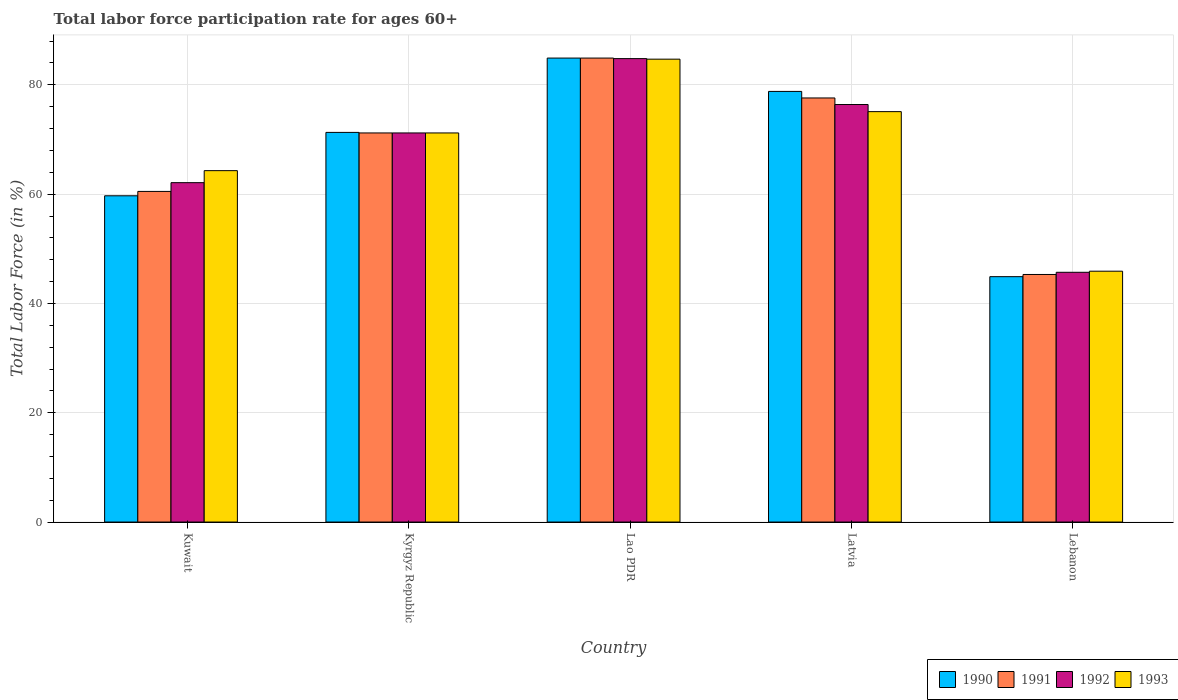How many groups of bars are there?
Give a very brief answer. 5. Are the number of bars on each tick of the X-axis equal?
Your answer should be very brief. Yes. What is the label of the 3rd group of bars from the left?
Give a very brief answer. Lao PDR. In how many cases, is the number of bars for a given country not equal to the number of legend labels?
Make the answer very short. 0. What is the labor force participation rate in 1993 in Lao PDR?
Your response must be concise. 84.7. Across all countries, what is the maximum labor force participation rate in 1992?
Provide a succinct answer. 84.8. Across all countries, what is the minimum labor force participation rate in 1992?
Ensure brevity in your answer.  45.7. In which country was the labor force participation rate in 1991 maximum?
Keep it short and to the point. Lao PDR. In which country was the labor force participation rate in 1992 minimum?
Provide a succinct answer. Lebanon. What is the total labor force participation rate in 1992 in the graph?
Provide a short and direct response. 340.2. What is the difference between the labor force participation rate in 1993 in Kuwait and that in Latvia?
Give a very brief answer. -10.8. What is the difference between the labor force participation rate in 1990 in Lebanon and the labor force participation rate in 1991 in Latvia?
Provide a short and direct response. -32.7. What is the average labor force participation rate in 1992 per country?
Your answer should be compact. 68.04. In how many countries, is the labor force participation rate in 1990 greater than 56 %?
Your answer should be very brief. 4. What is the ratio of the labor force participation rate in 1992 in Kuwait to that in Lebanon?
Keep it short and to the point. 1.36. Is the labor force participation rate in 1993 in Kyrgyz Republic less than that in Latvia?
Provide a short and direct response. Yes. Is the difference between the labor force participation rate in 1991 in Lao PDR and Lebanon greater than the difference between the labor force participation rate in 1990 in Lao PDR and Lebanon?
Provide a short and direct response. No. What is the difference between the highest and the second highest labor force participation rate in 1992?
Ensure brevity in your answer.  13.6. What is the difference between the highest and the lowest labor force participation rate in 1991?
Your answer should be compact. 39.6. Is the sum of the labor force participation rate in 1990 in Kyrgyz Republic and Lebanon greater than the maximum labor force participation rate in 1993 across all countries?
Make the answer very short. Yes. Is it the case that in every country, the sum of the labor force participation rate in 1992 and labor force participation rate in 1993 is greater than the sum of labor force participation rate in 1990 and labor force participation rate in 1991?
Provide a short and direct response. No. What does the 3rd bar from the left in Latvia represents?
Offer a very short reply. 1992. Is it the case that in every country, the sum of the labor force participation rate in 1990 and labor force participation rate in 1991 is greater than the labor force participation rate in 1993?
Ensure brevity in your answer.  Yes. How many bars are there?
Your answer should be very brief. 20. Are all the bars in the graph horizontal?
Offer a very short reply. No. Are the values on the major ticks of Y-axis written in scientific E-notation?
Provide a short and direct response. No. Does the graph contain grids?
Give a very brief answer. Yes. Where does the legend appear in the graph?
Provide a succinct answer. Bottom right. What is the title of the graph?
Offer a very short reply. Total labor force participation rate for ages 60+. What is the Total Labor Force (in %) in 1990 in Kuwait?
Provide a short and direct response. 59.7. What is the Total Labor Force (in %) in 1991 in Kuwait?
Your response must be concise. 60.5. What is the Total Labor Force (in %) of 1992 in Kuwait?
Your response must be concise. 62.1. What is the Total Labor Force (in %) of 1993 in Kuwait?
Give a very brief answer. 64.3. What is the Total Labor Force (in %) in 1990 in Kyrgyz Republic?
Make the answer very short. 71.3. What is the Total Labor Force (in %) of 1991 in Kyrgyz Republic?
Give a very brief answer. 71.2. What is the Total Labor Force (in %) in 1992 in Kyrgyz Republic?
Ensure brevity in your answer.  71.2. What is the Total Labor Force (in %) in 1993 in Kyrgyz Republic?
Your answer should be compact. 71.2. What is the Total Labor Force (in %) of 1990 in Lao PDR?
Make the answer very short. 84.9. What is the Total Labor Force (in %) in 1991 in Lao PDR?
Keep it short and to the point. 84.9. What is the Total Labor Force (in %) in 1992 in Lao PDR?
Provide a succinct answer. 84.8. What is the Total Labor Force (in %) of 1993 in Lao PDR?
Provide a succinct answer. 84.7. What is the Total Labor Force (in %) in 1990 in Latvia?
Your response must be concise. 78.8. What is the Total Labor Force (in %) of 1991 in Latvia?
Give a very brief answer. 77.6. What is the Total Labor Force (in %) of 1992 in Latvia?
Provide a short and direct response. 76.4. What is the Total Labor Force (in %) in 1993 in Latvia?
Provide a short and direct response. 75.1. What is the Total Labor Force (in %) in 1990 in Lebanon?
Your answer should be very brief. 44.9. What is the Total Labor Force (in %) in 1991 in Lebanon?
Offer a very short reply. 45.3. What is the Total Labor Force (in %) in 1992 in Lebanon?
Your answer should be very brief. 45.7. What is the Total Labor Force (in %) in 1993 in Lebanon?
Your response must be concise. 45.9. Across all countries, what is the maximum Total Labor Force (in %) in 1990?
Give a very brief answer. 84.9. Across all countries, what is the maximum Total Labor Force (in %) in 1991?
Provide a succinct answer. 84.9. Across all countries, what is the maximum Total Labor Force (in %) of 1992?
Your response must be concise. 84.8. Across all countries, what is the maximum Total Labor Force (in %) in 1993?
Keep it short and to the point. 84.7. Across all countries, what is the minimum Total Labor Force (in %) of 1990?
Your answer should be compact. 44.9. Across all countries, what is the minimum Total Labor Force (in %) in 1991?
Your response must be concise. 45.3. Across all countries, what is the minimum Total Labor Force (in %) of 1992?
Offer a very short reply. 45.7. Across all countries, what is the minimum Total Labor Force (in %) of 1993?
Make the answer very short. 45.9. What is the total Total Labor Force (in %) in 1990 in the graph?
Provide a short and direct response. 339.6. What is the total Total Labor Force (in %) of 1991 in the graph?
Your answer should be very brief. 339.5. What is the total Total Labor Force (in %) in 1992 in the graph?
Provide a short and direct response. 340.2. What is the total Total Labor Force (in %) in 1993 in the graph?
Offer a very short reply. 341.2. What is the difference between the Total Labor Force (in %) of 1990 in Kuwait and that in Kyrgyz Republic?
Your response must be concise. -11.6. What is the difference between the Total Labor Force (in %) in 1991 in Kuwait and that in Kyrgyz Republic?
Provide a short and direct response. -10.7. What is the difference between the Total Labor Force (in %) in 1992 in Kuwait and that in Kyrgyz Republic?
Your response must be concise. -9.1. What is the difference between the Total Labor Force (in %) of 1990 in Kuwait and that in Lao PDR?
Give a very brief answer. -25.2. What is the difference between the Total Labor Force (in %) of 1991 in Kuwait and that in Lao PDR?
Provide a succinct answer. -24.4. What is the difference between the Total Labor Force (in %) in 1992 in Kuwait and that in Lao PDR?
Provide a succinct answer. -22.7. What is the difference between the Total Labor Force (in %) of 1993 in Kuwait and that in Lao PDR?
Keep it short and to the point. -20.4. What is the difference between the Total Labor Force (in %) in 1990 in Kuwait and that in Latvia?
Ensure brevity in your answer.  -19.1. What is the difference between the Total Labor Force (in %) in 1991 in Kuwait and that in Latvia?
Your answer should be compact. -17.1. What is the difference between the Total Labor Force (in %) in 1992 in Kuwait and that in Latvia?
Your answer should be very brief. -14.3. What is the difference between the Total Labor Force (in %) in 1990 in Kuwait and that in Lebanon?
Give a very brief answer. 14.8. What is the difference between the Total Labor Force (in %) of 1991 in Kuwait and that in Lebanon?
Your answer should be very brief. 15.2. What is the difference between the Total Labor Force (in %) of 1992 in Kuwait and that in Lebanon?
Give a very brief answer. 16.4. What is the difference between the Total Labor Force (in %) of 1993 in Kuwait and that in Lebanon?
Your answer should be compact. 18.4. What is the difference between the Total Labor Force (in %) of 1991 in Kyrgyz Republic and that in Lao PDR?
Your response must be concise. -13.7. What is the difference between the Total Labor Force (in %) of 1990 in Kyrgyz Republic and that in Latvia?
Keep it short and to the point. -7.5. What is the difference between the Total Labor Force (in %) in 1990 in Kyrgyz Republic and that in Lebanon?
Provide a short and direct response. 26.4. What is the difference between the Total Labor Force (in %) in 1991 in Kyrgyz Republic and that in Lebanon?
Your response must be concise. 25.9. What is the difference between the Total Labor Force (in %) of 1992 in Kyrgyz Republic and that in Lebanon?
Keep it short and to the point. 25.5. What is the difference between the Total Labor Force (in %) in 1993 in Kyrgyz Republic and that in Lebanon?
Provide a succinct answer. 25.3. What is the difference between the Total Labor Force (in %) in 1990 in Lao PDR and that in Latvia?
Provide a succinct answer. 6.1. What is the difference between the Total Labor Force (in %) of 1991 in Lao PDR and that in Latvia?
Ensure brevity in your answer.  7.3. What is the difference between the Total Labor Force (in %) in 1993 in Lao PDR and that in Latvia?
Your response must be concise. 9.6. What is the difference between the Total Labor Force (in %) in 1990 in Lao PDR and that in Lebanon?
Provide a short and direct response. 40. What is the difference between the Total Labor Force (in %) in 1991 in Lao PDR and that in Lebanon?
Give a very brief answer. 39.6. What is the difference between the Total Labor Force (in %) of 1992 in Lao PDR and that in Lebanon?
Offer a very short reply. 39.1. What is the difference between the Total Labor Force (in %) in 1993 in Lao PDR and that in Lebanon?
Offer a terse response. 38.8. What is the difference between the Total Labor Force (in %) of 1990 in Latvia and that in Lebanon?
Your answer should be compact. 33.9. What is the difference between the Total Labor Force (in %) of 1991 in Latvia and that in Lebanon?
Provide a succinct answer. 32.3. What is the difference between the Total Labor Force (in %) in 1992 in Latvia and that in Lebanon?
Provide a succinct answer. 30.7. What is the difference between the Total Labor Force (in %) in 1993 in Latvia and that in Lebanon?
Offer a very short reply. 29.2. What is the difference between the Total Labor Force (in %) in 1990 in Kuwait and the Total Labor Force (in %) in 1991 in Kyrgyz Republic?
Make the answer very short. -11.5. What is the difference between the Total Labor Force (in %) in 1990 in Kuwait and the Total Labor Force (in %) in 1993 in Kyrgyz Republic?
Offer a very short reply. -11.5. What is the difference between the Total Labor Force (in %) of 1991 in Kuwait and the Total Labor Force (in %) of 1992 in Kyrgyz Republic?
Keep it short and to the point. -10.7. What is the difference between the Total Labor Force (in %) of 1991 in Kuwait and the Total Labor Force (in %) of 1993 in Kyrgyz Republic?
Provide a short and direct response. -10.7. What is the difference between the Total Labor Force (in %) of 1992 in Kuwait and the Total Labor Force (in %) of 1993 in Kyrgyz Republic?
Your response must be concise. -9.1. What is the difference between the Total Labor Force (in %) in 1990 in Kuwait and the Total Labor Force (in %) in 1991 in Lao PDR?
Offer a terse response. -25.2. What is the difference between the Total Labor Force (in %) of 1990 in Kuwait and the Total Labor Force (in %) of 1992 in Lao PDR?
Ensure brevity in your answer.  -25.1. What is the difference between the Total Labor Force (in %) in 1990 in Kuwait and the Total Labor Force (in %) in 1993 in Lao PDR?
Provide a succinct answer. -25. What is the difference between the Total Labor Force (in %) in 1991 in Kuwait and the Total Labor Force (in %) in 1992 in Lao PDR?
Ensure brevity in your answer.  -24.3. What is the difference between the Total Labor Force (in %) of 1991 in Kuwait and the Total Labor Force (in %) of 1993 in Lao PDR?
Provide a short and direct response. -24.2. What is the difference between the Total Labor Force (in %) of 1992 in Kuwait and the Total Labor Force (in %) of 1993 in Lao PDR?
Your answer should be very brief. -22.6. What is the difference between the Total Labor Force (in %) of 1990 in Kuwait and the Total Labor Force (in %) of 1991 in Latvia?
Offer a terse response. -17.9. What is the difference between the Total Labor Force (in %) of 1990 in Kuwait and the Total Labor Force (in %) of 1992 in Latvia?
Provide a succinct answer. -16.7. What is the difference between the Total Labor Force (in %) of 1990 in Kuwait and the Total Labor Force (in %) of 1993 in Latvia?
Your answer should be compact. -15.4. What is the difference between the Total Labor Force (in %) in 1991 in Kuwait and the Total Labor Force (in %) in 1992 in Latvia?
Make the answer very short. -15.9. What is the difference between the Total Labor Force (in %) in 1991 in Kuwait and the Total Labor Force (in %) in 1993 in Latvia?
Your answer should be compact. -14.6. What is the difference between the Total Labor Force (in %) of 1992 in Kuwait and the Total Labor Force (in %) of 1993 in Latvia?
Your answer should be very brief. -13. What is the difference between the Total Labor Force (in %) of 1990 in Kuwait and the Total Labor Force (in %) of 1991 in Lebanon?
Keep it short and to the point. 14.4. What is the difference between the Total Labor Force (in %) of 1990 in Kuwait and the Total Labor Force (in %) of 1992 in Lebanon?
Ensure brevity in your answer.  14. What is the difference between the Total Labor Force (in %) in 1991 in Kuwait and the Total Labor Force (in %) in 1992 in Lebanon?
Ensure brevity in your answer.  14.8. What is the difference between the Total Labor Force (in %) of 1991 in Kuwait and the Total Labor Force (in %) of 1993 in Lebanon?
Your answer should be very brief. 14.6. What is the difference between the Total Labor Force (in %) in 1992 in Kuwait and the Total Labor Force (in %) in 1993 in Lebanon?
Your response must be concise. 16.2. What is the difference between the Total Labor Force (in %) of 1991 in Kyrgyz Republic and the Total Labor Force (in %) of 1992 in Lao PDR?
Ensure brevity in your answer.  -13.6. What is the difference between the Total Labor Force (in %) in 1991 in Kyrgyz Republic and the Total Labor Force (in %) in 1993 in Lao PDR?
Your response must be concise. -13.5. What is the difference between the Total Labor Force (in %) of 1990 in Kyrgyz Republic and the Total Labor Force (in %) of 1992 in Latvia?
Provide a succinct answer. -5.1. What is the difference between the Total Labor Force (in %) of 1991 in Kyrgyz Republic and the Total Labor Force (in %) of 1992 in Latvia?
Your answer should be compact. -5.2. What is the difference between the Total Labor Force (in %) of 1991 in Kyrgyz Republic and the Total Labor Force (in %) of 1993 in Latvia?
Ensure brevity in your answer.  -3.9. What is the difference between the Total Labor Force (in %) in 1992 in Kyrgyz Republic and the Total Labor Force (in %) in 1993 in Latvia?
Offer a very short reply. -3.9. What is the difference between the Total Labor Force (in %) in 1990 in Kyrgyz Republic and the Total Labor Force (in %) in 1991 in Lebanon?
Provide a succinct answer. 26. What is the difference between the Total Labor Force (in %) of 1990 in Kyrgyz Republic and the Total Labor Force (in %) of 1992 in Lebanon?
Your answer should be very brief. 25.6. What is the difference between the Total Labor Force (in %) in 1990 in Kyrgyz Republic and the Total Labor Force (in %) in 1993 in Lebanon?
Your answer should be compact. 25.4. What is the difference between the Total Labor Force (in %) of 1991 in Kyrgyz Republic and the Total Labor Force (in %) of 1993 in Lebanon?
Provide a succinct answer. 25.3. What is the difference between the Total Labor Force (in %) of 1992 in Kyrgyz Republic and the Total Labor Force (in %) of 1993 in Lebanon?
Provide a short and direct response. 25.3. What is the difference between the Total Labor Force (in %) in 1990 in Lao PDR and the Total Labor Force (in %) in 1991 in Latvia?
Provide a succinct answer. 7.3. What is the difference between the Total Labor Force (in %) in 1990 in Lao PDR and the Total Labor Force (in %) in 1992 in Latvia?
Your answer should be compact. 8.5. What is the difference between the Total Labor Force (in %) in 1990 in Lao PDR and the Total Labor Force (in %) in 1993 in Latvia?
Ensure brevity in your answer.  9.8. What is the difference between the Total Labor Force (in %) in 1991 in Lao PDR and the Total Labor Force (in %) in 1993 in Latvia?
Make the answer very short. 9.8. What is the difference between the Total Labor Force (in %) in 1990 in Lao PDR and the Total Labor Force (in %) in 1991 in Lebanon?
Offer a terse response. 39.6. What is the difference between the Total Labor Force (in %) of 1990 in Lao PDR and the Total Labor Force (in %) of 1992 in Lebanon?
Your answer should be very brief. 39.2. What is the difference between the Total Labor Force (in %) of 1991 in Lao PDR and the Total Labor Force (in %) of 1992 in Lebanon?
Offer a very short reply. 39.2. What is the difference between the Total Labor Force (in %) of 1992 in Lao PDR and the Total Labor Force (in %) of 1993 in Lebanon?
Your response must be concise. 38.9. What is the difference between the Total Labor Force (in %) in 1990 in Latvia and the Total Labor Force (in %) in 1991 in Lebanon?
Keep it short and to the point. 33.5. What is the difference between the Total Labor Force (in %) in 1990 in Latvia and the Total Labor Force (in %) in 1992 in Lebanon?
Provide a succinct answer. 33.1. What is the difference between the Total Labor Force (in %) of 1990 in Latvia and the Total Labor Force (in %) of 1993 in Lebanon?
Your answer should be compact. 32.9. What is the difference between the Total Labor Force (in %) of 1991 in Latvia and the Total Labor Force (in %) of 1992 in Lebanon?
Your answer should be compact. 31.9. What is the difference between the Total Labor Force (in %) of 1991 in Latvia and the Total Labor Force (in %) of 1993 in Lebanon?
Your answer should be compact. 31.7. What is the difference between the Total Labor Force (in %) in 1992 in Latvia and the Total Labor Force (in %) in 1993 in Lebanon?
Offer a terse response. 30.5. What is the average Total Labor Force (in %) of 1990 per country?
Provide a short and direct response. 67.92. What is the average Total Labor Force (in %) of 1991 per country?
Your answer should be compact. 67.9. What is the average Total Labor Force (in %) in 1992 per country?
Your response must be concise. 68.04. What is the average Total Labor Force (in %) in 1993 per country?
Your answer should be very brief. 68.24. What is the difference between the Total Labor Force (in %) in 1990 and Total Labor Force (in %) in 1992 in Kuwait?
Make the answer very short. -2.4. What is the difference between the Total Labor Force (in %) of 1991 and Total Labor Force (in %) of 1992 in Kuwait?
Your answer should be very brief. -1.6. What is the difference between the Total Labor Force (in %) of 1991 and Total Labor Force (in %) of 1993 in Kuwait?
Provide a short and direct response. -3.8. What is the difference between the Total Labor Force (in %) in 1990 and Total Labor Force (in %) in 1992 in Kyrgyz Republic?
Keep it short and to the point. 0.1. What is the difference between the Total Labor Force (in %) of 1991 and Total Labor Force (in %) of 1992 in Kyrgyz Republic?
Ensure brevity in your answer.  0. What is the difference between the Total Labor Force (in %) of 1991 and Total Labor Force (in %) of 1993 in Kyrgyz Republic?
Make the answer very short. 0. What is the difference between the Total Labor Force (in %) of 1992 and Total Labor Force (in %) of 1993 in Kyrgyz Republic?
Your response must be concise. 0. What is the difference between the Total Labor Force (in %) in 1990 and Total Labor Force (in %) in 1992 in Lao PDR?
Your answer should be very brief. 0.1. What is the difference between the Total Labor Force (in %) of 1991 and Total Labor Force (in %) of 1992 in Lao PDR?
Your answer should be compact. 0.1. What is the difference between the Total Labor Force (in %) in 1991 and Total Labor Force (in %) in 1993 in Lao PDR?
Your answer should be very brief. 0.2. What is the difference between the Total Labor Force (in %) in 1992 and Total Labor Force (in %) in 1993 in Lao PDR?
Your answer should be compact. 0.1. What is the difference between the Total Labor Force (in %) in 1990 and Total Labor Force (in %) in 1991 in Latvia?
Your answer should be very brief. 1.2. What is the difference between the Total Labor Force (in %) in 1990 and Total Labor Force (in %) in 1993 in Latvia?
Make the answer very short. 3.7. What is the difference between the Total Labor Force (in %) of 1991 and Total Labor Force (in %) of 1993 in Latvia?
Provide a short and direct response. 2.5. What is the difference between the Total Labor Force (in %) of 1992 and Total Labor Force (in %) of 1993 in Latvia?
Provide a short and direct response. 1.3. What is the difference between the Total Labor Force (in %) in 1990 and Total Labor Force (in %) in 1991 in Lebanon?
Give a very brief answer. -0.4. What is the difference between the Total Labor Force (in %) in 1990 and Total Labor Force (in %) in 1992 in Lebanon?
Give a very brief answer. -0.8. What is the ratio of the Total Labor Force (in %) in 1990 in Kuwait to that in Kyrgyz Republic?
Your answer should be compact. 0.84. What is the ratio of the Total Labor Force (in %) in 1991 in Kuwait to that in Kyrgyz Republic?
Make the answer very short. 0.85. What is the ratio of the Total Labor Force (in %) in 1992 in Kuwait to that in Kyrgyz Republic?
Ensure brevity in your answer.  0.87. What is the ratio of the Total Labor Force (in %) of 1993 in Kuwait to that in Kyrgyz Republic?
Your answer should be very brief. 0.9. What is the ratio of the Total Labor Force (in %) of 1990 in Kuwait to that in Lao PDR?
Your answer should be very brief. 0.7. What is the ratio of the Total Labor Force (in %) of 1991 in Kuwait to that in Lao PDR?
Provide a succinct answer. 0.71. What is the ratio of the Total Labor Force (in %) in 1992 in Kuwait to that in Lao PDR?
Offer a terse response. 0.73. What is the ratio of the Total Labor Force (in %) in 1993 in Kuwait to that in Lao PDR?
Give a very brief answer. 0.76. What is the ratio of the Total Labor Force (in %) in 1990 in Kuwait to that in Latvia?
Provide a succinct answer. 0.76. What is the ratio of the Total Labor Force (in %) of 1991 in Kuwait to that in Latvia?
Offer a very short reply. 0.78. What is the ratio of the Total Labor Force (in %) in 1992 in Kuwait to that in Latvia?
Give a very brief answer. 0.81. What is the ratio of the Total Labor Force (in %) in 1993 in Kuwait to that in Latvia?
Provide a short and direct response. 0.86. What is the ratio of the Total Labor Force (in %) of 1990 in Kuwait to that in Lebanon?
Provide a succinct answer. 1.33. What is the ratio of the Total Labor Force (in %) in 1991 in Kuwait to that in Lebanon?
Your answer should be compact. 1.34. What is the ratio of the Total Labor Force (in %) of 1992 in Kuwait to that in Lebanon?
Give a very brief answer. 1.36. What is the ratio of the Total Labor Force (in %) in 1993 in Kuwait to that in Lebanon?
Make the answer very short. 1.4. What is the ratio of the Total Labor Force (in %) of 1990 in Kyrgyz Republic to that in Lao PDR?
Provide a succinct answer. 0.84. What is the ratio of the Total Labor Force (in %) of 1991 in Kyrgyz Republic to that in Lao PDR?
Offer a terse response. 0.84. What is the ratio of the Total Labor Force (in %) in 1992 in Kyrgyz Republic to that in Lao PDR?
Give a very brief answer. 0.84. What is the ratio of the Total Labor Force (in %) in 1993 in Kyrgyz Republic to that in Lao PDR?
Your answer should be very brief. 0.84. What is the ratio of the Total Labor Force (in %) in 1990 in Kyrgyz Republic to that in Latvia?
Keep it short and to the point. 0.9. What is the ratio of the Total Labor Force (in %) in 1991 in Kyrgyz Republic to that in Latvia?
Provide a succinct answer. 0.92. What is the ratio of the Total Labor Force (in %) of 1992 in Kyrgyz Republic to that in Latvia?
Offer a terse response. 0.93. What is the ratio of the Total Labor Force (in %) of 1993 in Kyrgyz Republic to that in Latvia?
Provide a short and direct response. 0.95. What is the ratio of the Total Labor Force (in %) of 1990 in Kyrgyz Republic to that in Lebanon?
Your response must be concise. 1.59. What is the ratio of the Total Labor Force (in %) in 1991 in Kyrgyz Republic to that in Lebanon?
Offer a terse response. 1.57. What is the ratio of the Total Labor Force (in %) in 1992 in Kyrgyz Republic to that in Lebanon?
Make the answer very short. 1.56. What is the ratio of the Total Labor Force (in %) of 1993 in Kyrgyz Republic to that in Lebanon?
Offer a very short reply. 1.55. What is the ratio of the Total Labor Force (in %) in 1990 in Lao PDR to that in Latvia?
Make the answer very short. 1.08. What is the ratio of the Total Labor Force (in %) of 1991 in Lao PDR to that in Latvia?
Ensure brevity in your answer.  1.09. What is the ratio of the Total Labor Force (in %) in 1992 in Lao PDR to that in Latvia?
Provide a short and direct response. 1.11. What is the ratio of the Total Labor Force (in %) of 1993 in Lao PDR to that in Latvia?
Keep it short and to the point. 1.13. What is the ratio of the Total Labor Force (in %) of 1990 in Lao PDR to that in Lebanon?
Offer a terse response. 1.89. What is the ratio of the Total Labor Force (in %) in 1991 in Lao PDR to that in Lebanon?
Offer a terse response. 1.87. What is the ratio of the Total Labor Force (in %) in 1992 in Lao PDR to that in Lebanon?
Your answer should be very brief. 1.86. What is the ratio of the Total Labor Force (in %) in 1993 in Lao PDR to that in Lebanon?
Offer a terse response. 1.85. What is the ratio of the Total Labor Force (in %) in 1990 in Latvia to that in Lebanon?
Your answer should be very brief. 1.75. What is the ratio of the Total Labor Force (in %) in 1991 in Latvia to that in Lebanon?
Make the answer very short. 1.71. What is the ratio of the Total Labor Force (in %) of 1992 in Latvia to that in Lebanon?
Keep it short and to the point. 1.67. What is the ratio of the Total Labor Force (in %) in 1993 in Latvia to that in Lebanon?
Give a very brief answer. 1.64. What is the difference between the highest and the second highest Total Labor Force (in %) of 1990?
Provide a short and direct response. 6.1. What is the difference between the highest and the second highest Total Labor Force (in %) in 1991?
Your answer should be compact. 7.3. What is the difference between the highest and the second highest Total Labor Force (in %) of 1992?
Make the answer very short. 8.4. What is the difference between the highest and the lowest Total Labor Force (in %) in 1991?
Keep it short and to the point. 39.6. What is the difference between the highest and the lowest Total Labor Force (in %) in 1992?
Offer a very short reply. 39.1. What is the difference between the highest and the lowest Total Labor Force (in %) in 1993?
Ensure brevity in your answer.  38.8. 